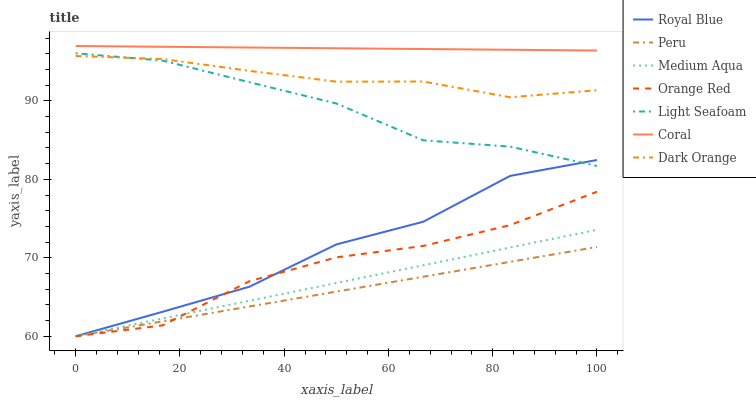Does Peru have the minimum area under the curve?
Answer yes or no. Yes. Does Coral have the maximum area under the curve?
Answer yes or no. Yes. Does Royal Blue have the minimum area under the curve?
Answer yes or no. No. Does Royal Blue have the maximum area under the curve?
Answer yes or no. No. Is Coral the smoothest?
Answer yes or no. Yes. Is Royal Blue the roughest?
Answer yes or no. Yes. Is Royal Blue the smoothest?
Answer yes or no. No. Is Coral the roughest?
Answer yes or no. No. Does Coral have the lowest value?
Answer yes or no. No. Does Coral have the highest value?
Answer yes or no. Yes. Does Royal Blue have the highest value?
Answer yes or no. No. Is Orange Red less than Dark Orange?
Answer yes or no. Yes. Is Coral greater than Royal Blue?
Answer yes or no. Yes. Does Medium Aqua intersect Peru?
Answer yes or no. Yes. Is Medium Aqua less than Peru?
Answer yes or no. No. Is Medium Aqua greater than Peru?
Answer yes or no. No. Does Orange Red intersect Dark Orange?
Answer yes or no. No. 